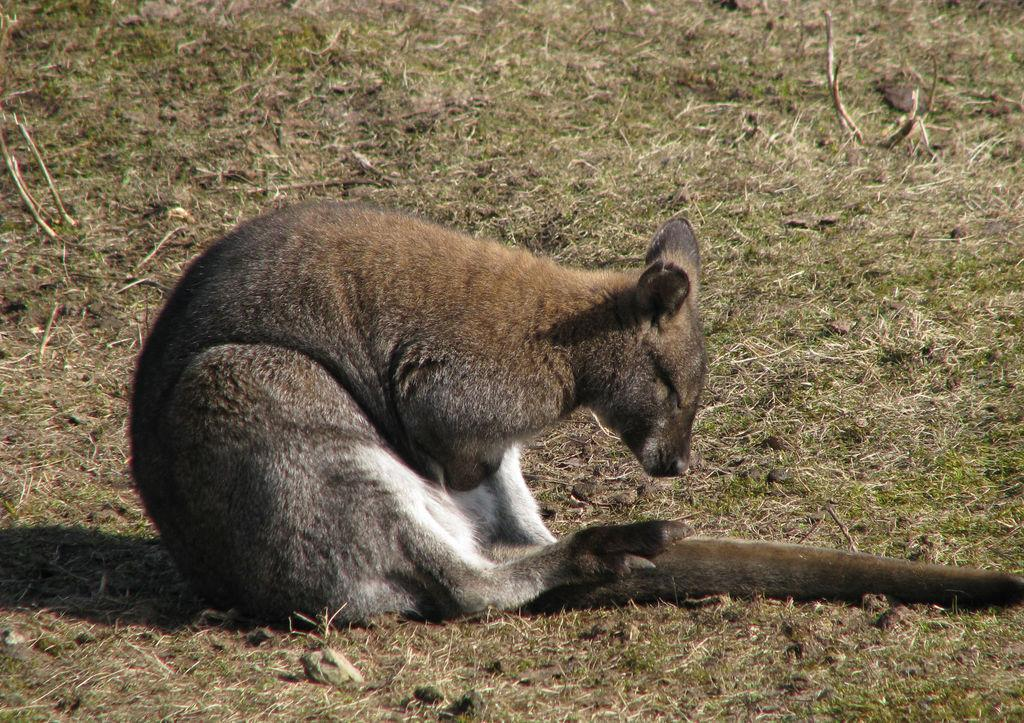What type of animal is in the image? The specific type of animal cannot be determined from the provided facts. What is the ground surface like in the image? The ground in the image is covered with grass. What type of wood is the animal wearing as a mask in the image? There is no wood or mask present in the image; it features an animal on grassy ground. How many teeth can be seen on the animal in the image? The number of teeth on the animal cannot be determined from the provided facts, as the animal's species is not specified. 